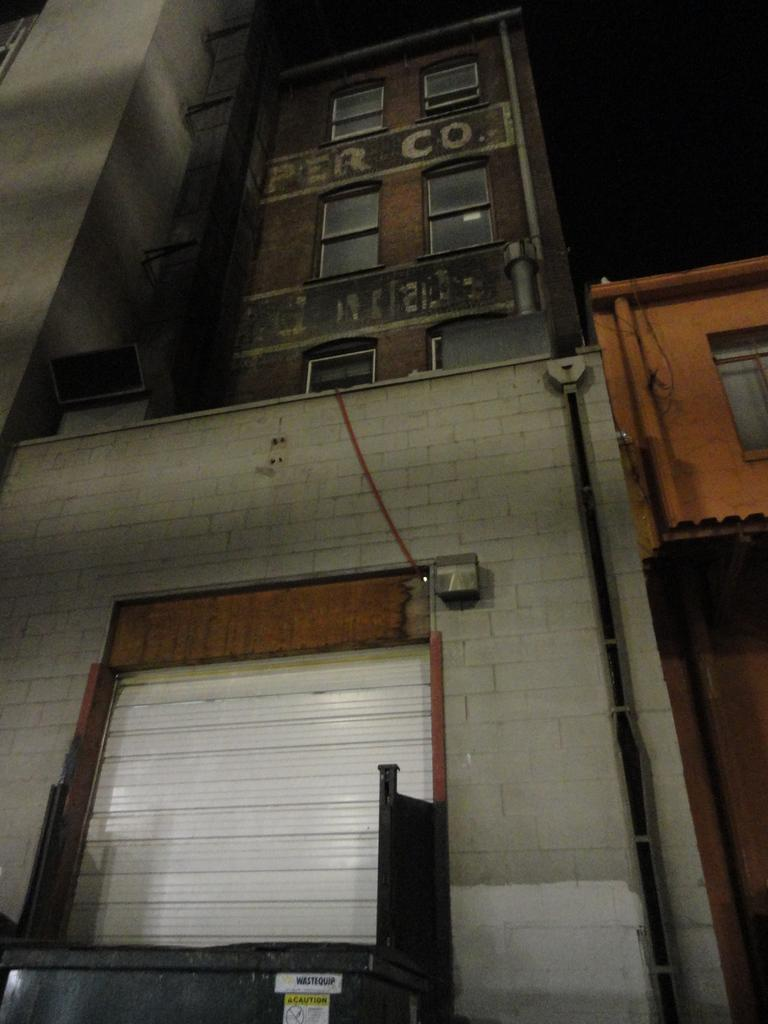What type of structures are present in the image? There are buildings in the image. Can you describe any specific features of the buildings? The buildings have windows. What can be seen on the right side of the image? There is a pipe on the right side of the image. What is located in the front of the image? There is a shutter in the front of the image. How would you describe the overall lighting in the image? The background of the image is dark. What flavor of ice cream is being served during the competition in the image? There is no ice cream or competition present in the image; it features buildings, a pipe, a shutter, and a dark background. 